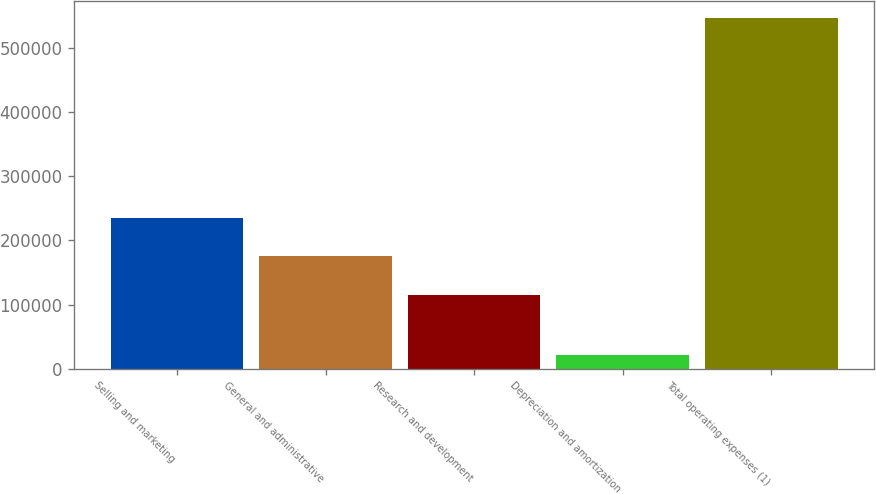Convert chart. <chart><loc_0><loc_0><loc_500><loc_500><bar_chart><fcel>Selling and marketing<fcel>General and administrative<fcel>Research and development<fcel>Depreciation and amortization<fcel>Total operating expenses (1)<nl><fcel>235341<fcel>175093<fcel>115043<fcel>21057<fcel>546534<nl></chart> 